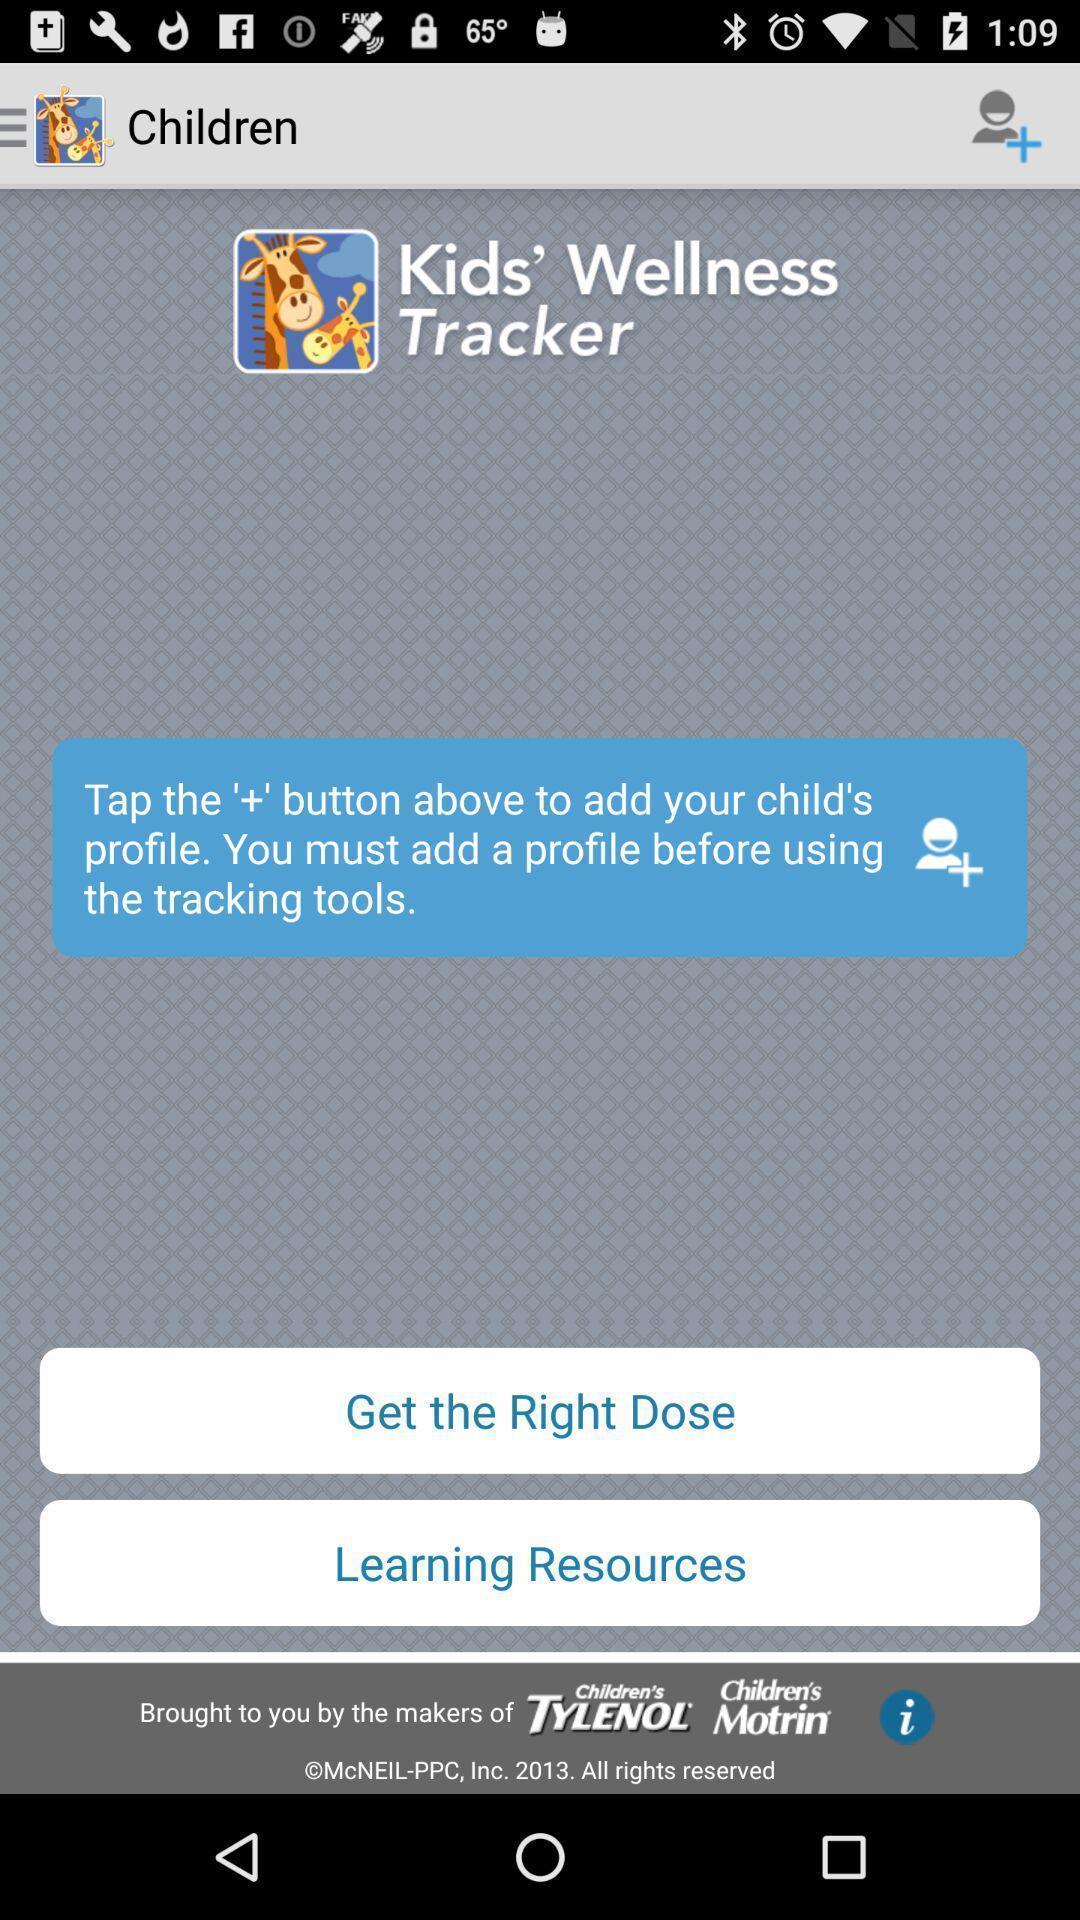Provide a textual representation of this image. Screen showing tap to add your child 's profile. 